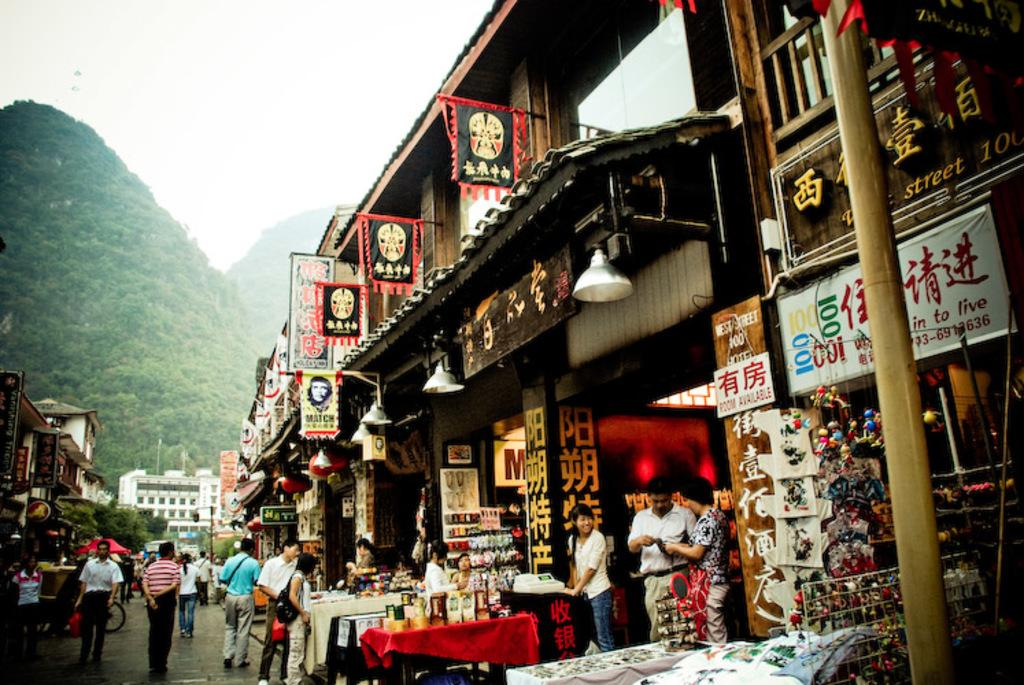<image>
Provide a brief description of the given image. West Street 100 is advertised on the banners along the street. 